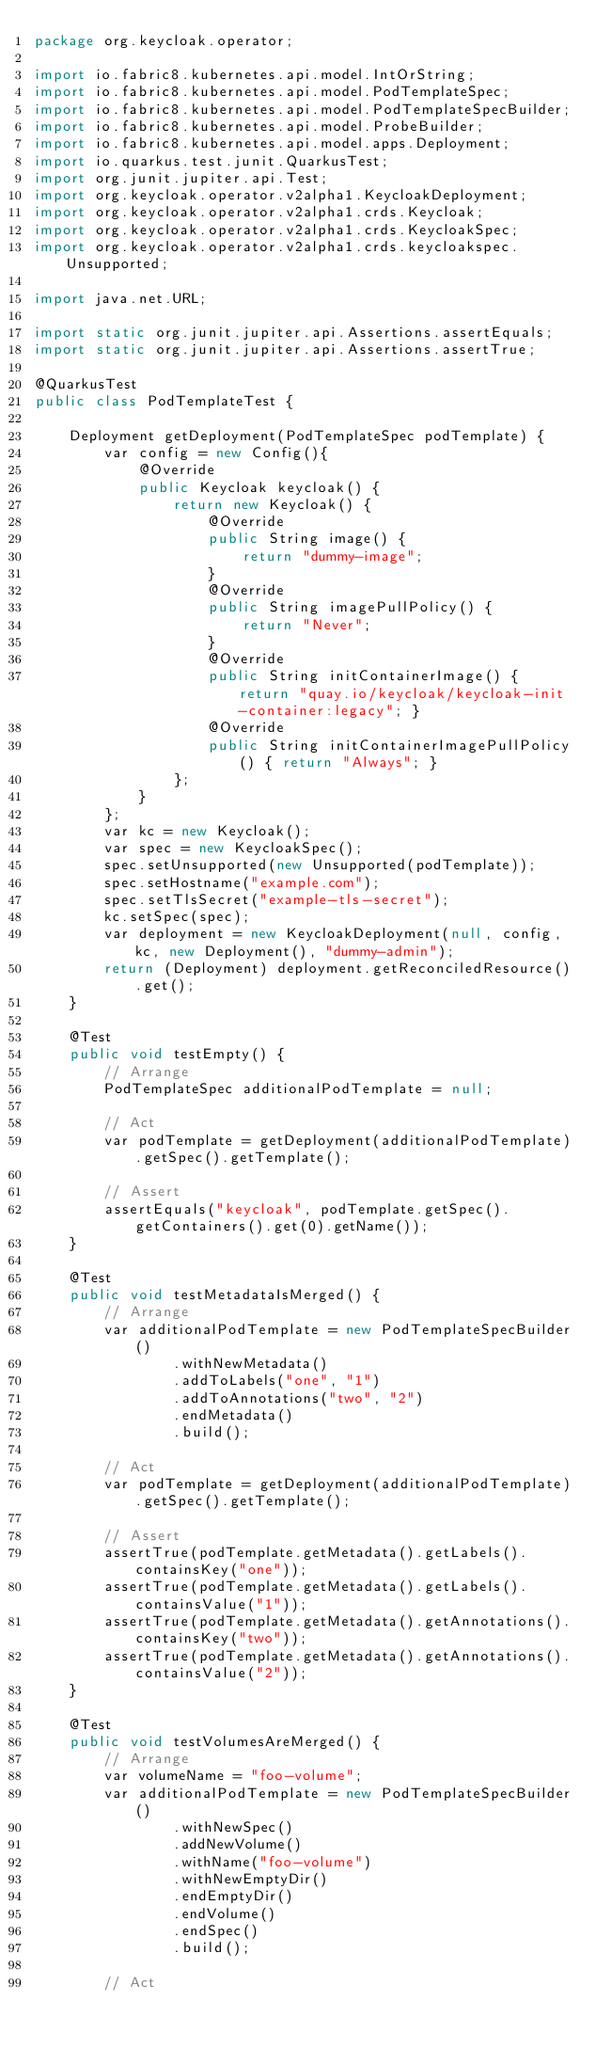<code> <loc_0><loc_0><loc_500><loc_500><_Java_>package org.keycloak.operator;

import io.fabric8.kubernetes.api.model.IntOrString;
import io.fabric8.kubernetes.api.model.PodTemplateSpec;
import io.fabric8.kubernetes.api.model.PodTemplateSpecBuilder;
import io.fabric8.kubernetes.api.model.ProbeBuilder;
import io.fabric8.kubernetes.api.model.apps.Deployment;
import io.quarkus.test.junit.QuarkusTest;
import org.junit.jupiter.api.Test;
import org.keycloak.operator.v2alpha1.KeycloakDeployment;
import org.keycloak.operator.v2alpha1.crds.Keycloak;
import org.keycloak.operator.v2alpha1.crds.KeycloakSpec;
import org.keycloak.operator.v2alpha1.crds.keycloakspec.Unsupported;

import java.net.URL;

import static org.junit.jupiter.api.Assertions.assertEquals;
import static org.junit.jupiter.api.Assertions.assertTrue;

@QuarkusTest
public class PodTemplateTest {

    Deployment getDeployment(PodTemplateSpec podTemplate) {
        var config = new Config(){
            @Override
            public Keycloak keycloak() {
                return new Keycloak() {
                    @Override
                    public String image() {
                        return "dummy-image";
                    }
                    @Override
                    public String imagePullPolicy() {
                        return "Never";
                    }
                    @Override
                    public String initContainerImage() { return "quay.io/keycloak/keycloak-init-container:legacy"; }
                    @Override
                    public String initContainerImagePullPolicy() { return "Always"; }
                };
            }
        };
        var kc = new Keycloak();
        var spec = new KeycloakSpec();
        spec.setUnsupported(new Unsupported(podTemplate));
        spec.setHostname("example.com");
        spec.setTlsSecret("example-tls-secret");
        kc.setSpec(spec);
        var deployment = new KeycloakDeployment(null, config, kc, new Deployment(), "dummy-admin");
        return (Deployment) deployment.getReconciledResource().get();
    }

    @Test
    public void testEmpty() {
        // Arrange
        PodTemplateSpec additionalPodTemplate = null;

        // Act
        var podTemplate = getDeployment(additionalPodTemplate).getSpec().getTemplate();

        // Assert
        assertEquals("keycloak", podTemplate.getSpec().getContainers().get(0).getName());
    }

    @Test
    public void testMetadataIsMerged() {
        // Arrange
        var additionalPodTemplate = new PodTemplateSpecBuilder()
                .withNewMetadata()
                .addToLabels("one", "1")
                .addToAnnotations("two", "2")
                .endMetadata()
                .build();

        // Act
        var podTemplate = getDeployment(additionalPodTemplate).getSpec().getTemplate();

        // Assert
        assertTrue(podTemplate.getMetadata().getLabels().containsKey("one"));
        assertTrue(podTemplate.getMetadata().getLabels().containsValue("1"));
        assertTrue(podTemplate.getMetadata().getAnnotations().containsKey("two"));
        assertTrue(podTemplate.getMetadata().getAnnotations().containsValue("2"));
    }

    @Test
    public void testVolumesAreMerged() {
        // Arrange
        var volumeName = "foo-volume";
        var additionalPodTemplate = new PodTemplateSpecBuilder()
                .withNewSpec()
                .addNewVolume()
                .withName("foo-volume")
                .withNewEmptyDir()
                .endEmptyDir()
                .endVolume()
                .endSpec()
                .build();

        // Act</code> 